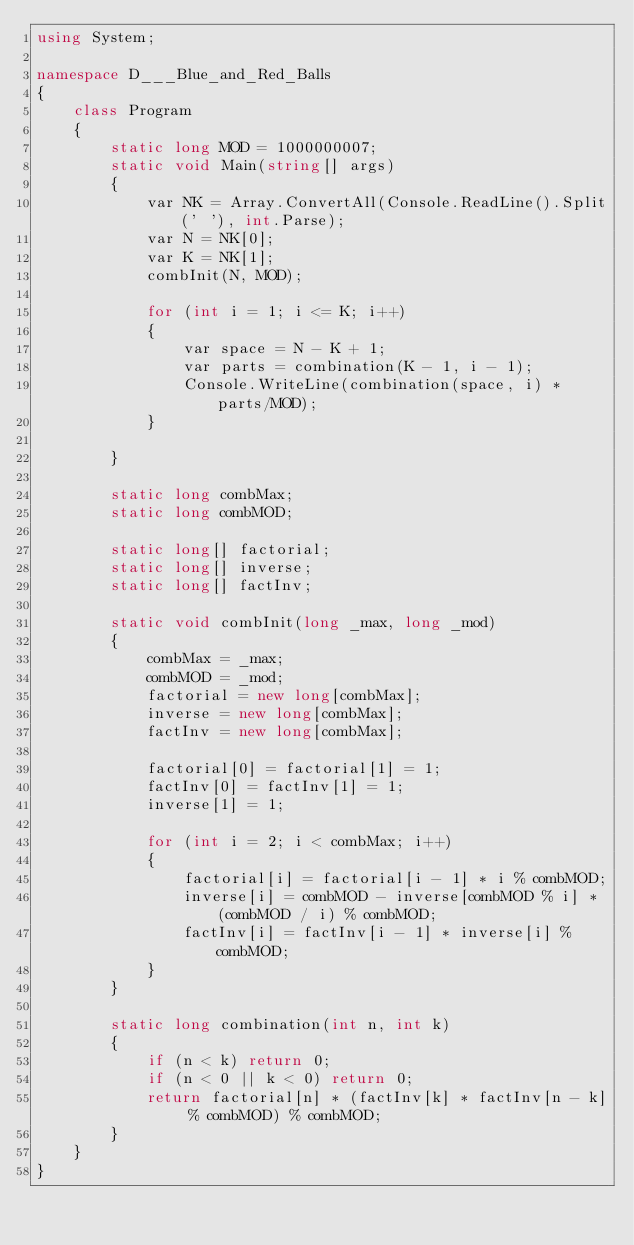Convert code to text. <code><loc_0><loc_0><loc_500><loc_500><_C#_>using System;

namespace D___Blue_and_Red_Balls
{
    class Program
    {
        static long MOD = 1000000007;
        static void Main(string[] args)
        {
            var NK = Array.ConvertAll(Console.ReadLine().Split(' '), int.Parse);
            var N = NK[0];
            var K = NK[1];
            combInit(N, MOD);

            for (int i = 1; i <= K; i++)
            {
                var space = N - K + 1;
                var parts = combination(K - 1, i - 1);
                Console.WriteLine(combination(space, i) * parts/MOD);
            }

        }

        static long combMax;
        static long combMOD;

        static long[] factorial;
        static long[] inverse;
        static long[] factInv;

        static void combInit(long _max, long _mod)
        {
            combMax = _max;
            combMOD = _mod;
            factorial = new long[combMax];
            inverse = new long[combMax];
            factInv = new long[combMax];

            factorial[0] = factorial[1] = 1;
            factInv[0] = factInv[1] = 1;
            inverse[1] = 1;

            for (int i = 2; i < combMax; i++)
            {
                factorial[i] = factorial[i - 1] * i % combMOD;
                inverse[i] = combMOD - inverse[combMOD % i] * (combMOD / i) % combMOD;
                factInv[i] = factInv[i - 1] * inverse[i] % combMOD;
            }
        }

        static long combination(int n, int k)
        {
            if (n < k) return 0;
            if (n < 0 || k < 0) return 0;
            return factorial[n] * (factInv[k] * factInv[n - k] % combMOD) % combMOD;
        }
    }
}
</code> 